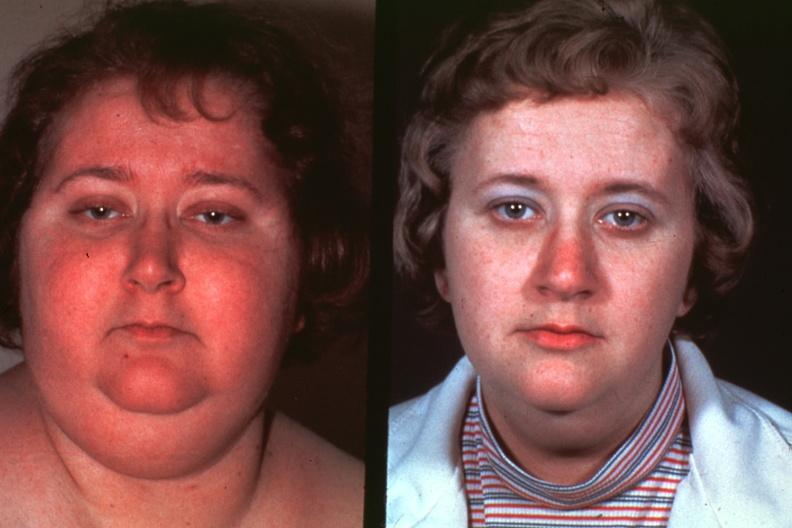what does this image show?
Answer the question using a single word or phrase. Photos of lady before disease and after excellent 